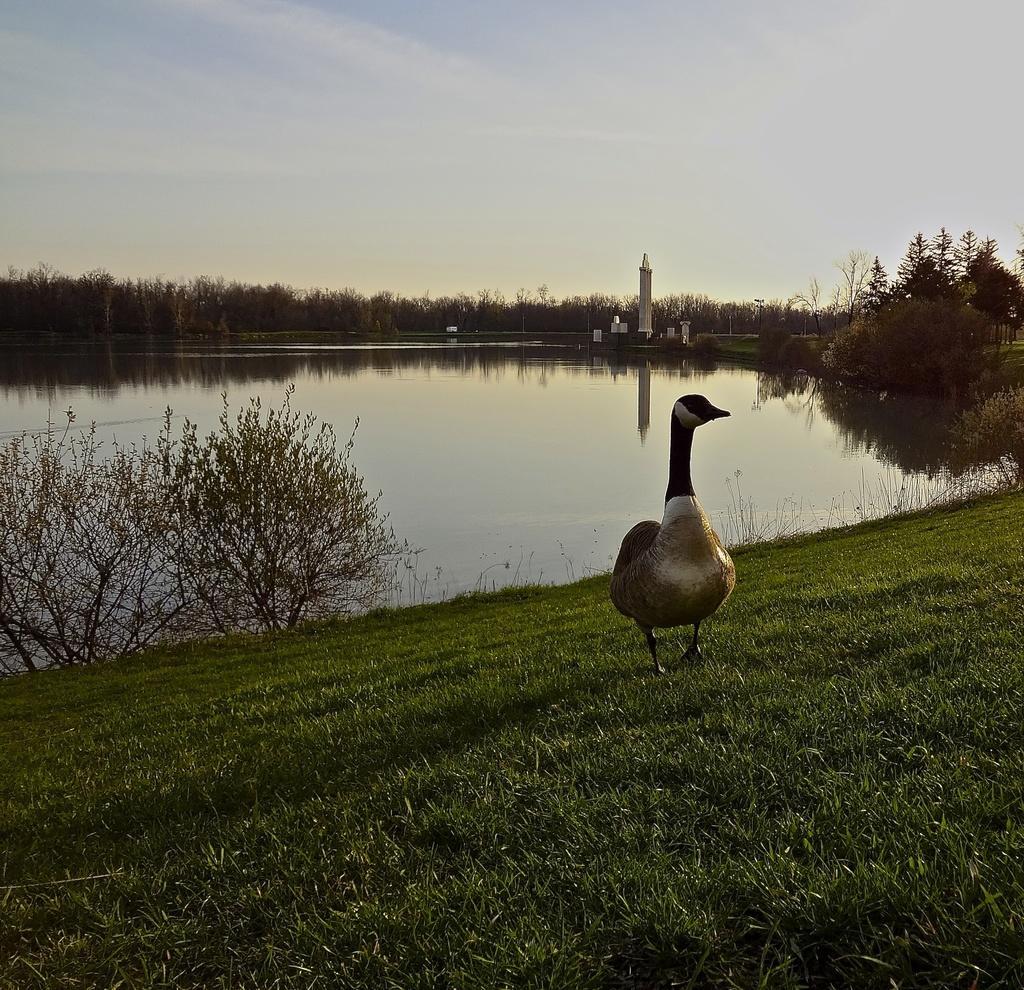How would you summarize this image in a sentence or two? In this picture there is a duck which is standing on the grass. On the left i see the plants, beside that i can see a river. In the background i can see the tower, building and many trees. At the top i can see the sky and clouds. 